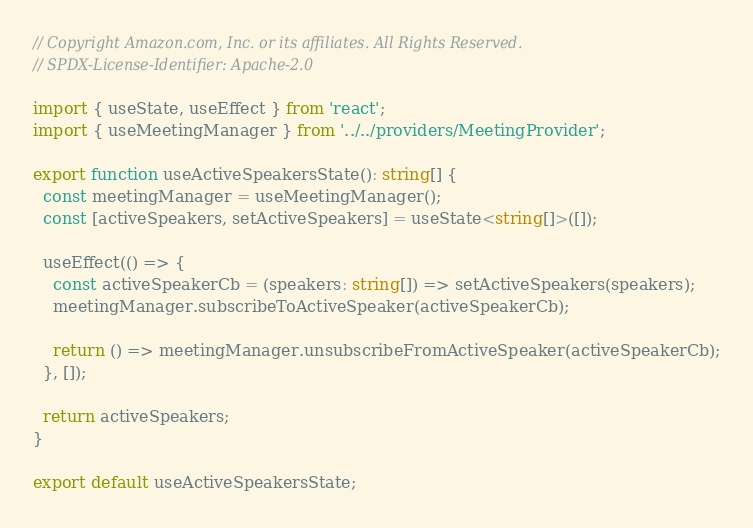Convert code to text. <code><loc_0><loc_0><loc_500><loc_500><_TypeScript_>// Copyright Amazon.com, Inc. or its affiliates. All Rights Reserved.
// SPDX-License-Identifier: Apache-2.0

import { useState, useEffect } from 'react';
import { useMeetingManager } from '../../providers/MeetingProvider';

export function useActiveSpeakersState(): string[] {
  const meetingManager = useMeetingManager();
  const [activeSpeakers, setActiveSpeakers] = useState<string[]>([]);

  useEffect(() => {
    const activeSpeakerCb = (speakers: string[]) => setActiveSpeakers(speakers);
    meetingManager.subscribeToActiveSpeaker(activeSpeakerCb);

    return () => meetingManager.unsubscribeFromActiveSpeaker(activeSpeakerCb);
  }, []);

  return activeSpeakers;
}

export default useActiveSpeakersState;
</code> 